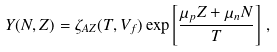<formula> <loc_0><loc_0><loc_500><loc_500>Y ( N , Z ) = \zeta _ { A Z } ( T , V _ { f } ) \exp \left [ \frac { \mu _ { p } Z + \mu _ { n } N } { T } \right ] \, ,</formula> 